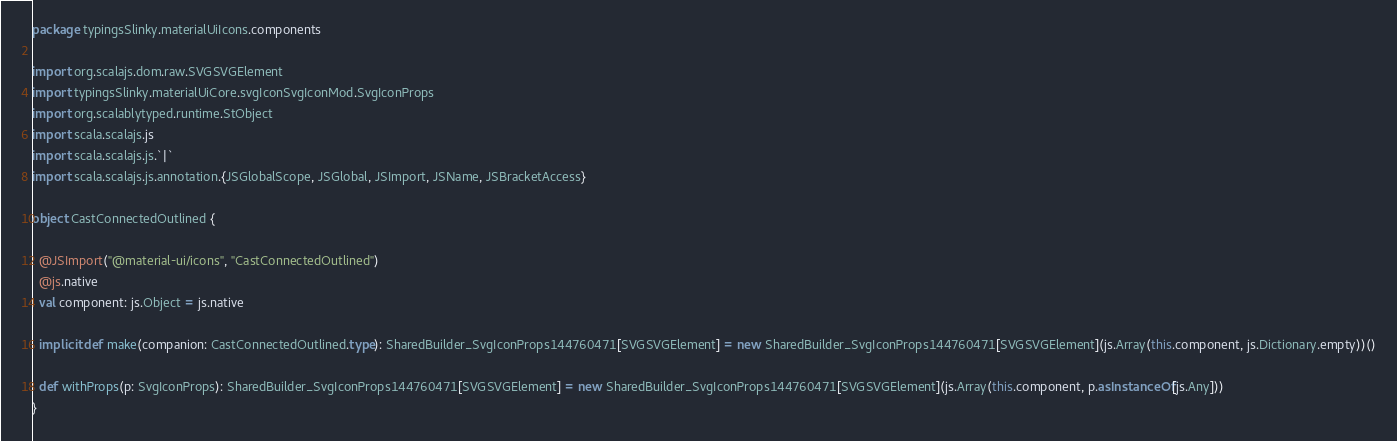Convert code to text. <code><loc_0><loc_0><loc_500><loc_500><_Scala_>package typingsSlinky.materialUiIcons.components

import org.scalajs.dom.raw.SVGSVGElement
import typingsSlinky.materialUiCore.svgIconSvgIconMod.SvgIconProps
import org.scalablytyped.runtime.StObject
import scala.scalajs.js
import scala.scalajs.js.`|`
import scala.scalajs.js.annotation.{JSGlobalScope, JSGlobal, JSImport, JSName, JSBracketAccess}

object CastConnectedOutlined {
  
  @JSImport("@material-ui/icons", "CastConnectedOutlined")
  @js.native
  val component: js.Object = js.native
  
  implicit def make(companion: CastConnectedOutlined.type): SharedBuilder_SvgIconProps144760471[SVGSVGElement] = new SharedBuilder_SvgIconProps144760471[SVGSVGElement](js.Array(this.component, js.Dictionary.empty))()
  
  def withProps(p: SvgIconProps): SharedBuilder_SvgIconProps144760471[SVGSVGElement] = new SharedBuilder_SvgIconProps144760471[SVGSVGElement](js.Array(this.component, p.asInstanceOf[js.Any]))
}
</code> 